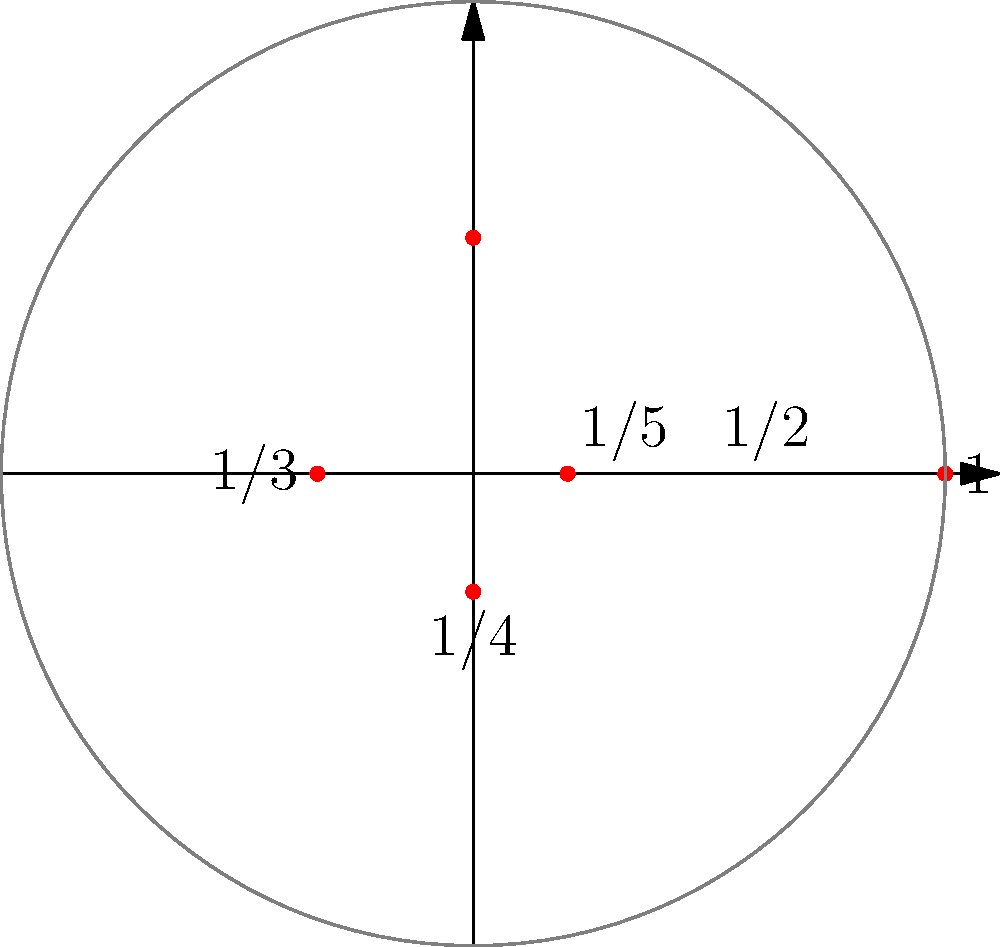As a cellist, you're analyzing the harmonic overtones of a C2 note (65.41 Hz) on your cello. The polar plot above represents the first five harmonics, where the radial distance represents the relative amplitude and the angle represents the phase. If the fundamental frequency (first harmonic) has an amplitude of 1, what is the amplitude of the third harmonic, and at what phase angle does it occur? To solve this problem, we need to analyze the polar plot and understand how harmonics are represented:

1. The fundamental frequency (first harmonic) is represented by the outermost point with a radius of 1.

2. Each subsequent harmonic has a decreasing amplitude, represented by points closer to the origin.

3. The harmonics are plotted in order, moving counterclockwise around the circle.

4. The radius of each point represents the relative amplitude of that harmonic.

5. The angle of each point represents the phase of that harmonic.

To find the third harmonic:

1. Count counterclockwise from the first point (on the positive x-axis) to the third point.

2. The third point is located on the negative x-axis.

3. Its radial distance from the origin is $\frac{1}{3}$ of the fundamental's amplitude.

4. Its angle is $\pi$ radians or 180 degrees.

Therefore, the third harmonic has an amplitude of $\frac{1}{3}$ relative to the fundamental, and it occurs at a phase angle of $\pi$ radians or 180 degrees.
Answer: Amplitude: $\frac{1}{3}$, Phase: $\pi$ radians 